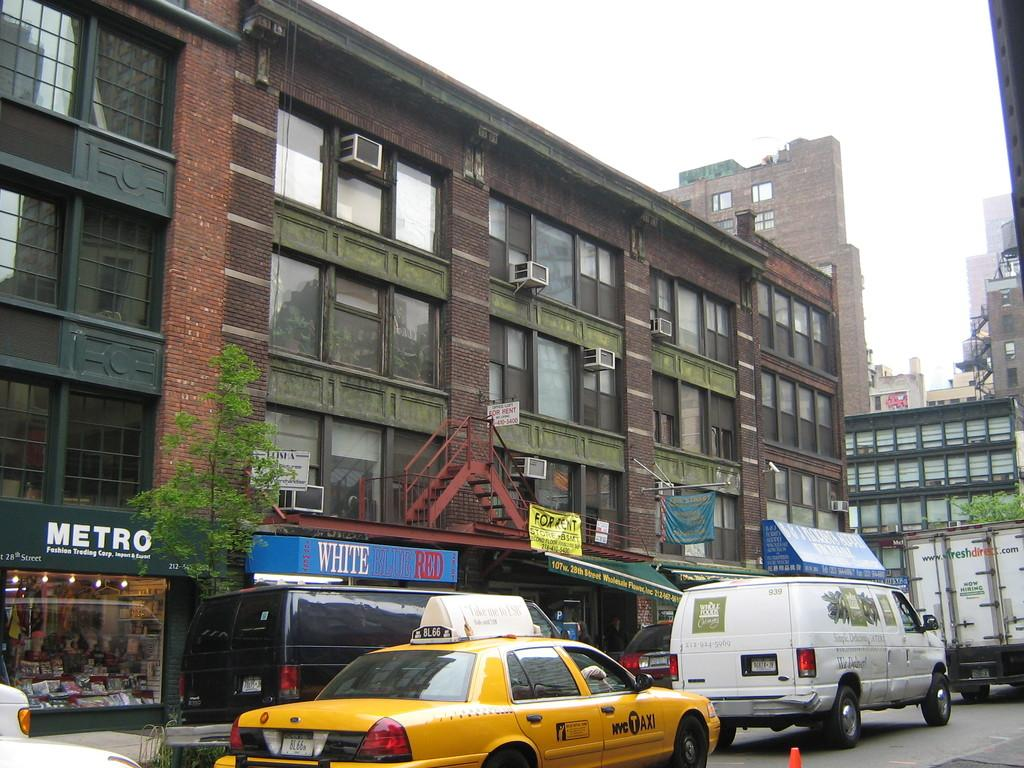Provide a one-sentence caption for the provided image. A yellow and black taxo parks outside a building that says Metro on it. 